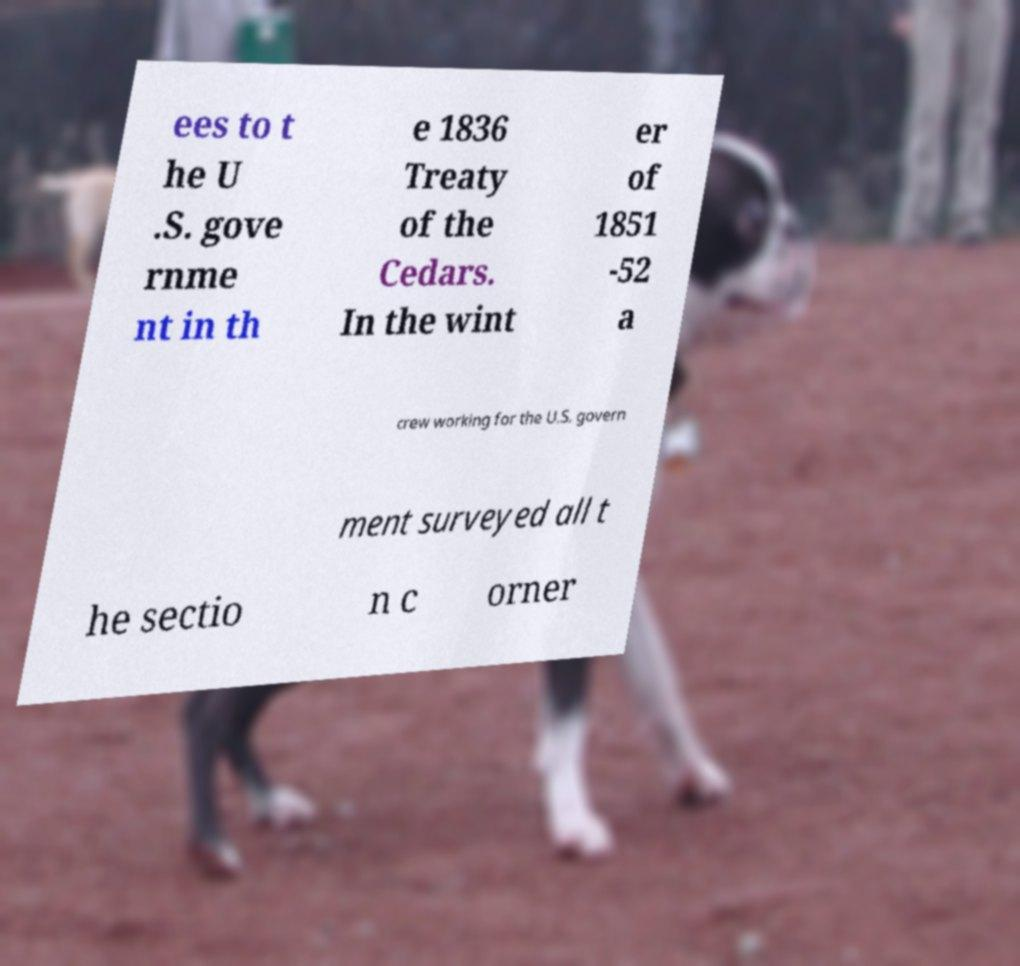There's text embedded in this image that I need extracted. Can you transcribe it verbatim? ees to t he U .S. gove rnme nt in th e 1836 Treaty of the Cedars. In the wint er of 1851 -52 a crew working for the U.S. govern ment surveyed all t he sectio n c orner 